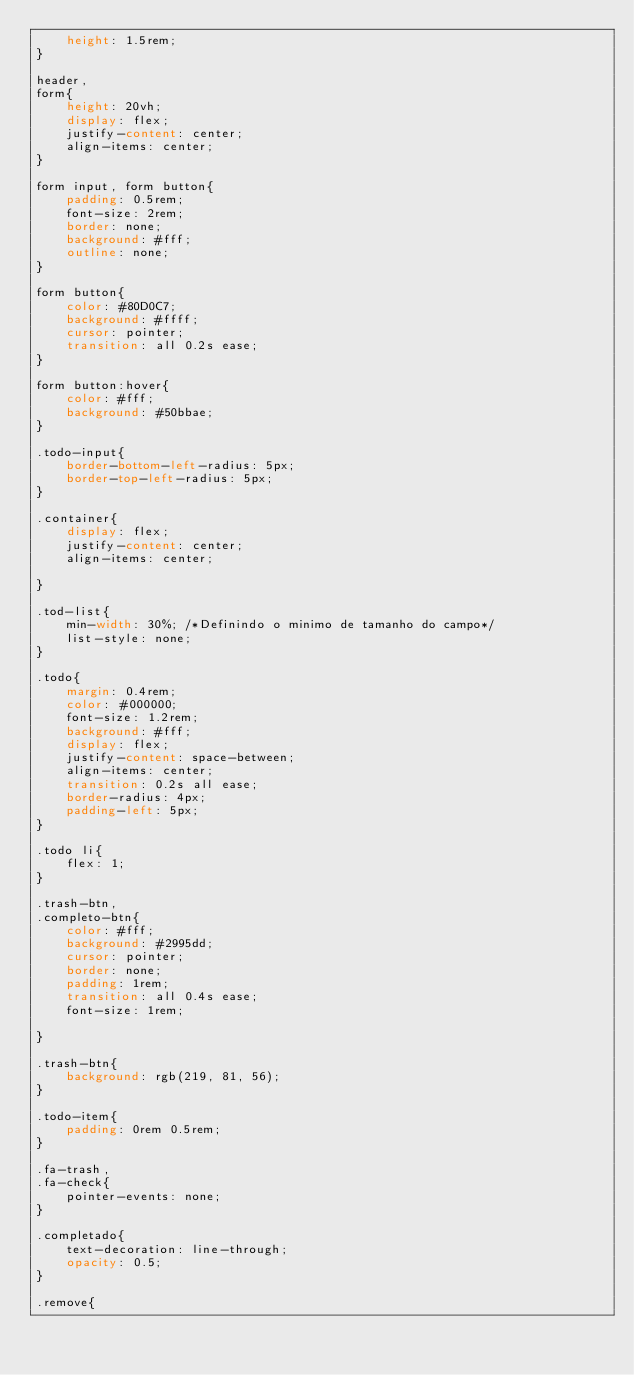<code> <loc_0><loc_0><loc_500><loc_500><_CSS_>    height: 1.5rem;
}

header,
form{
    height: 20vh;
    display: flex;
    justify-content: center;
    align-items: center;
}

form input, form button{
    padding: 0.5rem;
    font-size: 2rem;
    border: none;
    background: #fff;
    outline: none;
}

form button{
    color: #80D0C7;
    background: #ffff;
    cursor: pointer;
    transition: all 0.2s ease;
}

form button:hover{
    color: #fff;
    background: #50bbae;
}

.todo-input{
    border-bottom-left-radius: 5px;
    border-top-left-radius: 5px;
}

.container{
    display: flex;
    justify-content: center;
    align-items: center;
    
}

.tod-list{
    min-width: 30%; /*Definindo o minimo de tamanho do campo*/
    list-style: none;
}

.todo{
    margin: 0.4rem;
    color: #000000;
    font-size: 1.2rem;
    background: #fff;
    display: flex;
    justify-content: space-between;
    align-items: center;
    transition: 0.2s all ease;
    border-radius: 4px;
    padding-left: 5px;
}

.todo li{
    flex: 1;
}

.trash-btn, 
.completo-btn{
    color: #fff;
    background: #2995dd;
    cursor: pointer;
    border: none;
    padding: 1rem;
    transition: all 0.4s ease;
    font-size: 1rem;
   
}

.trash-btn{
    background: rgb(219, 81, 56);
}

.todo-item{
    padding: 0rem 0.5rem;
}

.fa-trash,
.fa-check{
    pointer-events: none;
}

.completado{
    text-decoration: line-through;
    opacity: 0.5;
}

.remove{</code> 